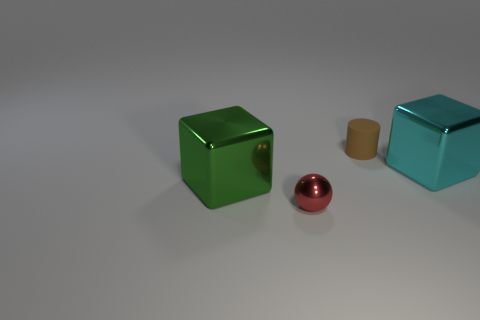What number of cyan things have the same material as the cyan cube?
Provide a short and direct response. 0. There is a big object that is the same material as the big cyan block; what color is it?
Offer a very short reply. Green. How big is the metallic block in front of the big object that is right of the block that is on the left side of the red sphere?
Offer a terse response. Large. Are there fewer tiny red spheres than small purple matte cylinders?
Make the answer very short. No. There is another metal thing that is the same shape as the green metallic thing; what is its color?
Your answer should be compact. Cyan. Are there any large green cubes to the right of the big metal block that is behind the big metallic thing that is in front of the cyan metal block?
Your response must be concise. No. Do the small red thing and the tiny brown object have the same shape?
Offer a very short reply. No. Is the number of large metal objects to the right of the large cyan shiny thing less than the number of cyan things?
Keep it short and to the point. Yes. What is the color of the big metal object that is on the left side of the shiny object that is on the right side of the object that is behind the cyan metal thing?
Keep it short and to the point. Green. How many shiny things are either gray cubes or big cyan blocks?
Provide a short and direct response. 1. 